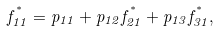Convert formula to latex. <formula><loc_0><loc_0><loc_500><loc_500>f _ { 1 1 } ^ { ^ { * } } = p _ { 1 1 } + p _ { 1 2 } f _ { 2 1 } ^ { ^ { * } } + p _ { 1 3 } f _ { 3 1 } ^ { ^ { * } } ,</formula> 